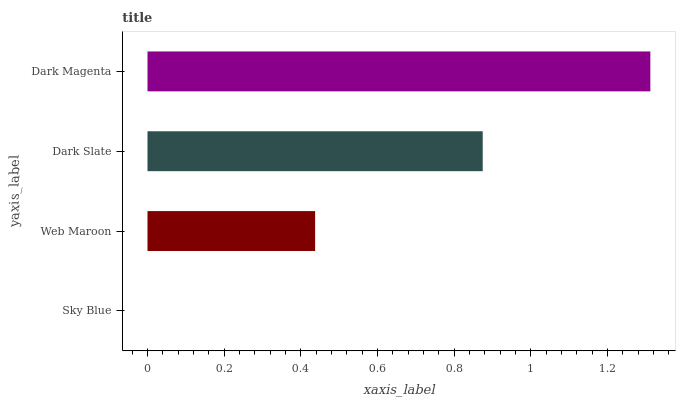Is Sky Blue the minimum?
Answer yes or no. Yes. Is Dark Magenta the maximum?
Answer yes or no. Yes. Is Web Maroon the minimum?
Answer yes or no. No. Is Web Maroon the maximum?
Answer yes or no. No. Is Web Maroon greater than Sky Blue?
Answer yes or no. Yes. Is Sky Blue less than Web Maroon?
Answer yes or no. Yes. Is Sky Blue greater than Web Maroon?
Answer yes or no. No. Is Web Maroon less than Sky Blue?
Answer yes or no. No. Is Dark Slate the high median?
Answer yes or no. Yes. Is Web Maroon the low median?
Answer yes or no. Yes. Is Dark Magenta the high median?
Answer yes or no. No. Is Dark Magenta the low median?
Answer yes or no. No. 